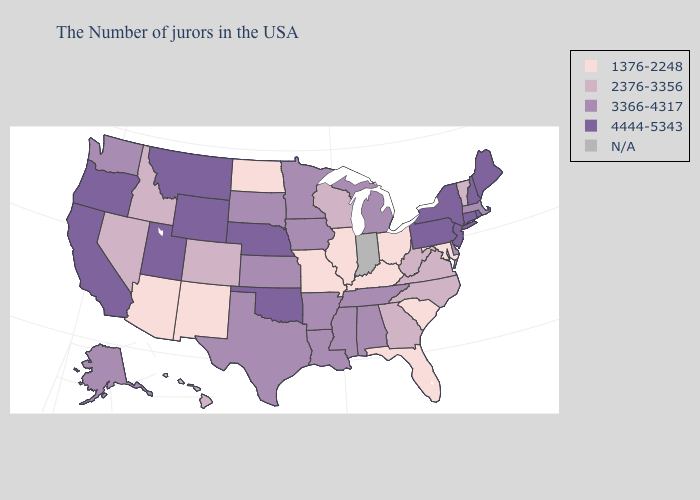Does Connecticut have the highest value in the USA?
Short answer required. Yes. Does Arizona have the lowest value in the USA?
Quick response, please. Yes. Name the states that have a value in the range 4444-5343?
Give a very brief answer. Maine, Rhode Island, New Hampshire, Connecticut, New York, New Jersey, Pennsylvania, Nebraska, Oklahoma, Wyoming, Utah, Montana, California, Oregon. Among the states that border Wisconsin , which have the lowest value?
Answer briefly. Illinois. Among the states that border New York , which have the highest value?
Keep it brief. Connecticut, New Jersey, Pennsylvania. Name the states that have a value in the range N/A?
Short answer required. Indiana. Name the states that have a value in the range 1376-2248?
Write a very short answer. Maryland, South Carolina, Ohio, Florida, Kentucky, Illinois, Missouri, North Dakota, New Mexico, Arizona. What is the value of South Dakota?
Keep it brief. 3366-4317. What is the highest value in states that border Nebraska?
Short answer required. 4444-5343. What is the lowest value in states that border Mississippi?
Give a very brief answer. 3366-4317. What is the value of Louisiana?
Keep it brief. 3366-4317. Name the states that have a value in the range 4444-5343?
Concise answer only. Maine, Rhode Island, New Hampshire, Connecticut, New York, New Jersey, Pennsylvania, Nebraska, Oklahoma, Wyoming, Utah, Montana, California, Oregon. Which states have the lowest value in the USA?
Write a very short answer. Maryland, South Carolina, Ohio, Florida, Kentucky, Illinois, Missouri, North Dakota, New Mexico, Arizona. 